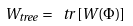<formula> <loc_0><loc_0><loc_500><loc_500>W _ { t r e e } = \ t r \left [ W ( \Phi ) \right ]</formula> 